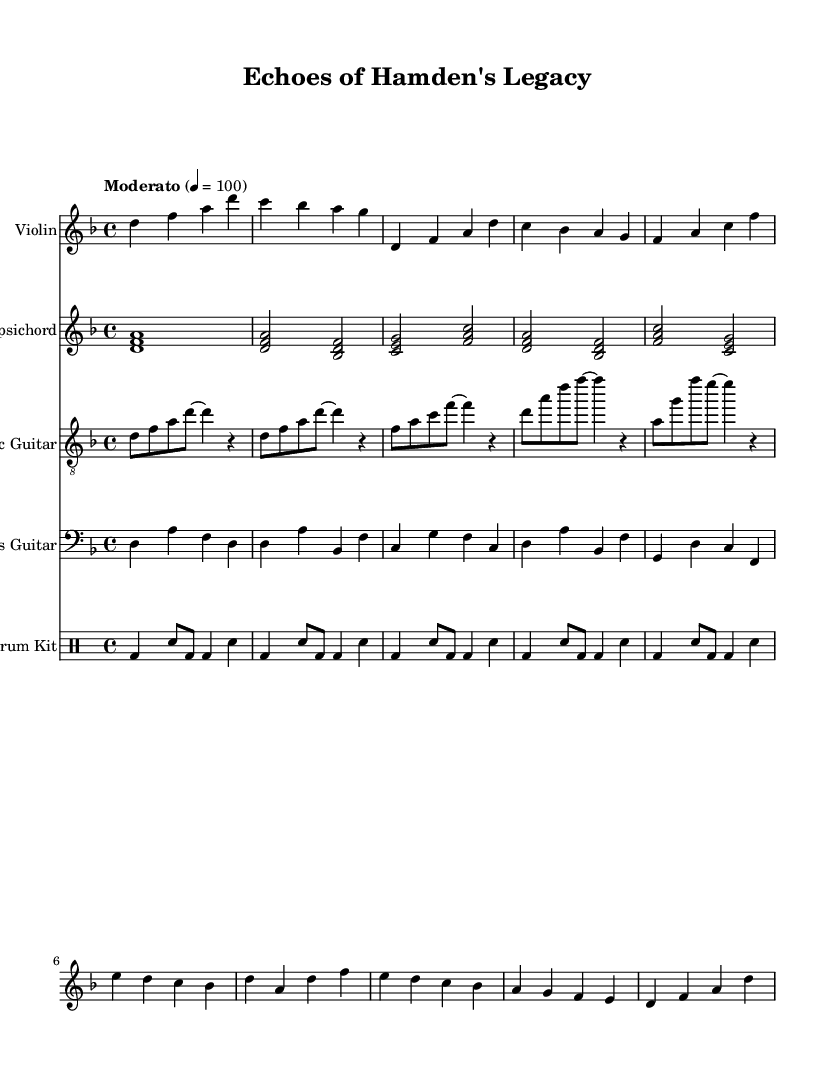What is the key signature of this music? The key signature is D minor, indicated by one flat (B flat). It can be identified by observing the key signature notation at the beginning of the staff.
Answer: D minor What is the time signature of this piece? The time signature is 4/4, shown at the beginning of the sheet music. This means there are four beats in each measure and the quarter note gets one beat.
Answer: 4/4 What is the tempo marking of this piece? The tempo marking indicates "Moderato" at quarter note equals 100, meaning the piece should be played at a moderate pace of 100 beats per minute. This is noted in the tempo line at the start.
Answer: Moderato How many sections are there in the piece? There are three sections in the music: Intro, Verse, and Chorus. The structure can be determined by looking for the distinct patterns and repetitions in the music notation.
Answer: Three What is the main instrument featured in the solo part? The main instrument featured in the solo part is the Violin, indicated by its separate staff at the beginning of the score.
Answer: Violin What style of music is being fused in this composition? The composition fuses Baroque and contemporary rock styles, as seen in the use of traditional instruments like harpsichord alongside modern elements such as electric guitar and drum kit.
Answer: Baroque and contemporary rock Which instrument plays the rhythm section? The rhythm section is played by the Drum Kit, which is indicated by its own staff and drum notation. It is typically responsible for maintaining the beat and supports the harmonic and melodic elements.
Answer: Drum Kit 